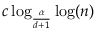<formula> <loc_0><loc_0><loc_500><loc_500>c \log _ { \frac { \alpha } { d + 1 } } \log ( n )</formula> 